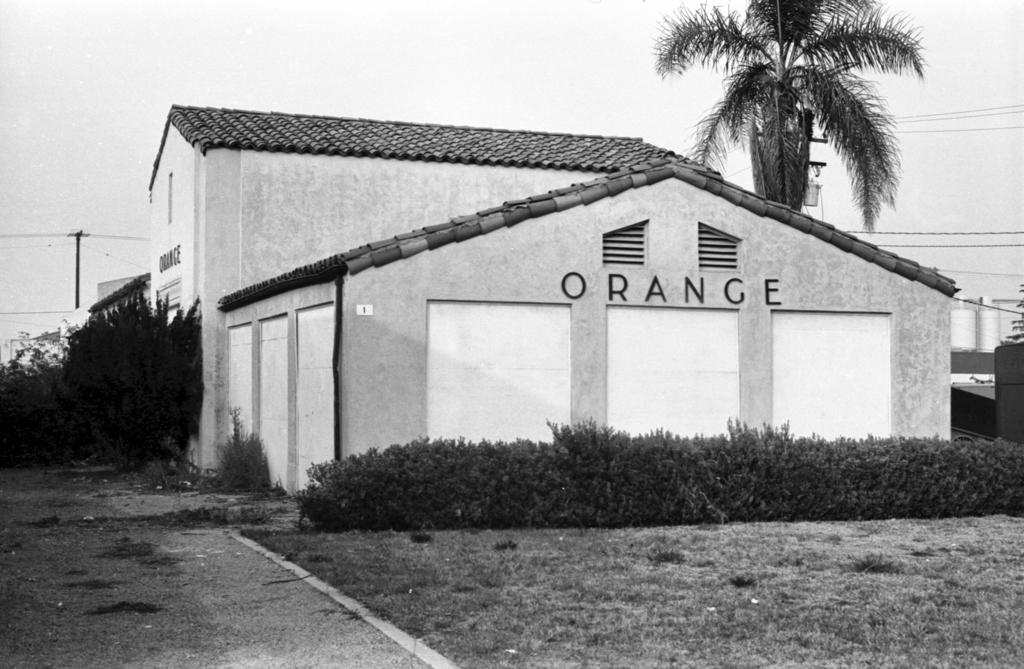What structures are visible in the image? There are buildings in the image. What type of natural elements can be seen in the image? There are trees in the image. What man-made objects are present in the image? There are electric poles in the image. What color scheme is used in the image? The image is in black and white. What type of protest is happening in the image? There is no protest visible in the image; it features buildings, trees, and electric poles in black and white. What size are the trees in the image? The size of the trees cannot be determined from the image alone, as there is no reference point for comparison. 